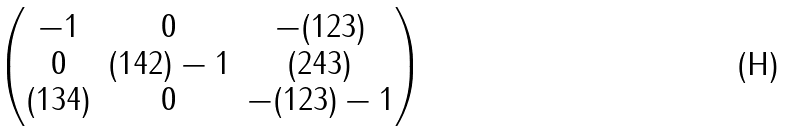<formula> <loc_0><loc_0><loc_500><loc_500>\begin{pmatrix} - 1 & 0 & - ( 1 2 3 ) \\ 0 & ( 1 4 2 ) - 1 & ( 2 4 3 ) \\ ( 1 3 4 ) & 0 & - ( 1 2 3 ) - 1 \end{pmatrix}</formula> 